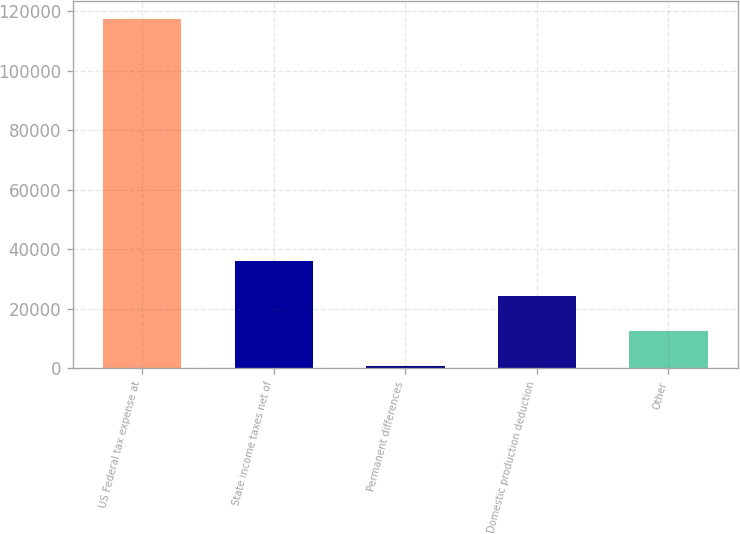Convert chart. <chart><loc_0><loc_0><loc_500><loc_500><bar_chart><fcel>US Federal tax expense at<fcel>State income taxes net of<fcel>Permanent differences<fcel>Domestic production deduction<fcel>Other<nl><fcel>117510<fcel>35936.9<fcel>977<fcel>24283.6<fcel>12630.3<nl></chart> 